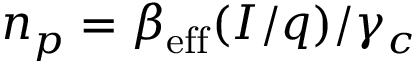Convert formula to latex. <formula><loc_0><loc_0><loc_500><loc_500>n _ { p } = \beta _ { e f f } ( I / q ) / \gamma _ { c }</formula> 